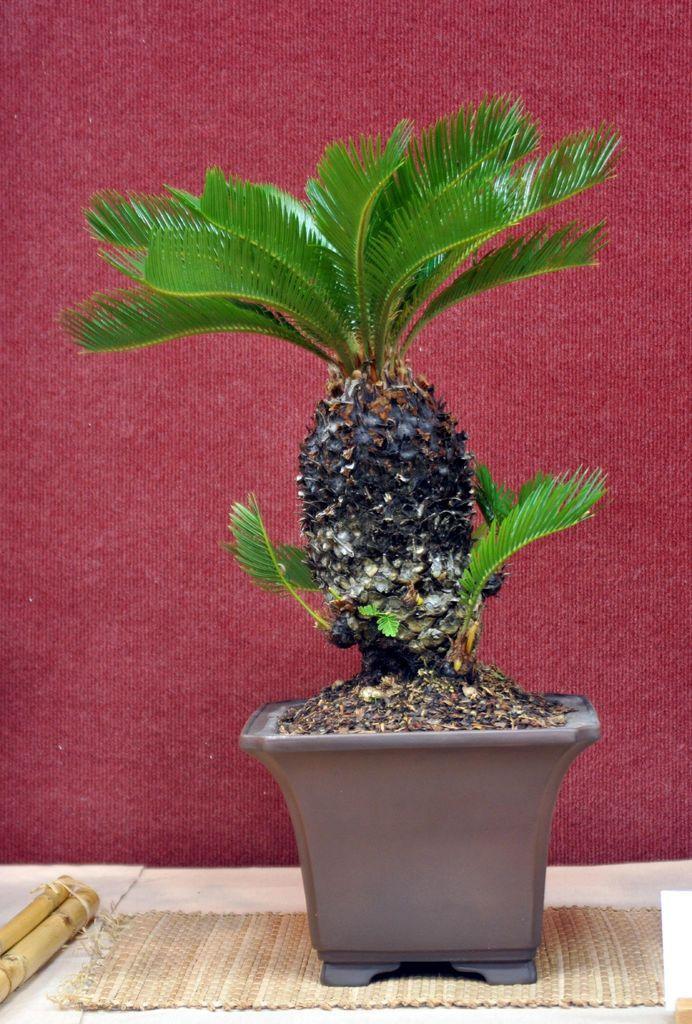Could you give a brief overview of what you see in this image? In this image we can see a plant on the flower pot, doormat and wooden sticks here. In the background, we can see the maroon color wall. 